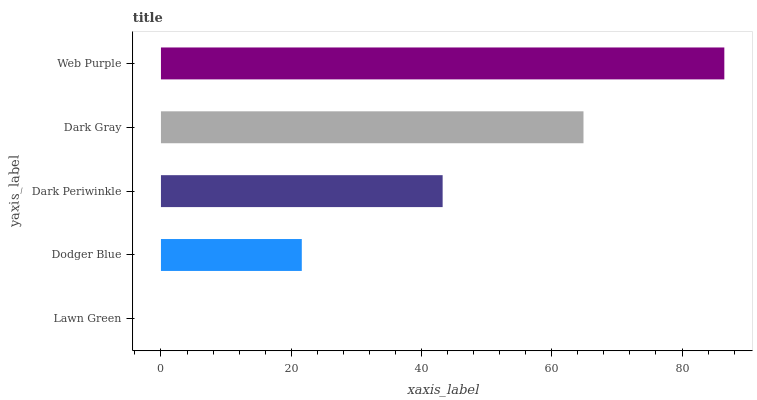Is Lawn Green the minimum?
Answer yes or no. Yes. Is Web Purple the maximum?
Answer yes or no. Yes. Is Dodger Blue the minimum?
Answer yes or no. No. Is Dodger Blue the maximum?
Answer yes or no. No. Is Dodger Blue greater than Lawn Green?
Answer yes or no. Yes. Is Lawn Green less than Dodger Blue?
Answer yes or no. Yes. Is Lawn Green greater than Dodger Blue?
Answer yes or no. No. Is Dodger Blue less than Lawn Green?
Answer yes or no. No. Is Dark Periwinkle the high median?
Answer yes or no. Yes. Is Dark Periwinkle the low median?
Answer yes or no. Yes. Is Dark Gray the high median?
Answer yes or no. No. Is Web Purple the low median?
Answer yes or no. No. 